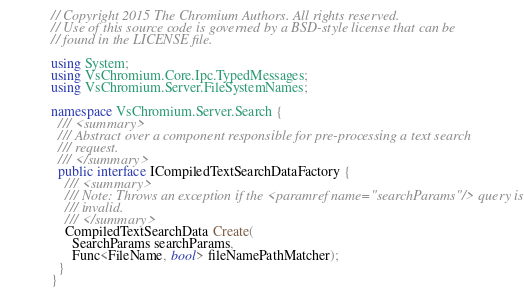Convert code to text. <code><loc_0><loc_0><loc_500><loc_500><_C#_>// Copyright 2015 The Chromium Authors. All rights reserved.
// Use of this source code is governed by a BSD-style license that can be
// found in the LICENSE file.

using System;
using VsChromium.Core.Ipc.TypedMessages;
using VsChromium.Server.FileSystemNames;

namespace VsChromium.Server.Search {
  /// <summary>
  /// Abstract over a component responsible for pre-processing a text search
  /// request.
  /// </summary>
  public interface ICompiledTextSearchDataFactory {
    /// <summary>
    /// Note: Throws an exception if the <paramref name="searchParams"/> query is
    /// invalid.
    /// </summary>
    CompiledTextSearchData Create(
      SearchParams searchParams,
      Func<FileName, bool> fileNamePathMatcher);
  }
}</code> 